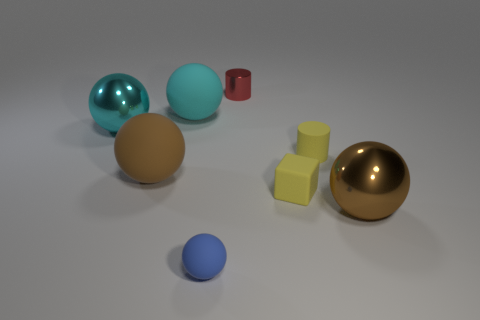Subtract all cyan metal spheres. How many spheres are left? 4 Add 1 small rubber things. How many objects exist? 9 Subtract all red cubes. How many cyan balls are left? 2 Subtract all cyan spheres. How many spheres are left? 3 Subtract all cylinders. How many objects are left? 6 Subtract 1 cylinders. How many cylinders are left? 1 Subtract all yellow balls. Subtract all cyan cylinders. How many balls are left? 5 Subtract all tiny purple balls. Subtract all large brown spheres. How many objects are left? 6 Add 5 tiny shiny things. How many tiny shiny things are left? 6 Add 5 yellow cubes. How many yellow cubes exist? 6 